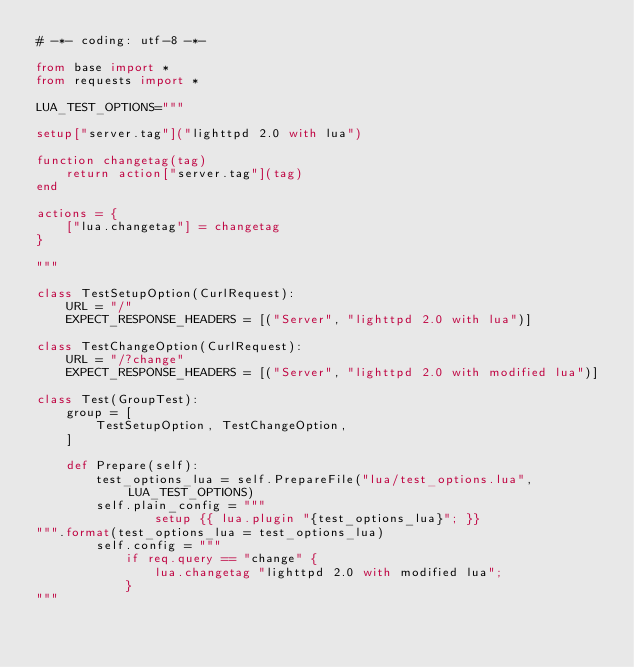Convert code to text. <code><loc_0><loc_0><loc_500><loc_500><_Python_># -*- coding: utf-8 -*-

from base import *
from requests import *

LUA_TEST_OPTIONS="""

setup["server.tag"]("lighttpd 2.0 with lua")

function changetag(tag)
	return action["server.tag"](tag)
end

actions = {
	["lua.changetag"] = changetag
}

"""

class TestSetupOption(CurlRequest):
	URL = "/"
	EXPECT_RESPONSE_HEADERS = [("Server", "lighttpd 2.0 with lua")]

class TestChangeOption(CurlRequest):
	URL = "/?change"
	EXPECT_RESPONSE_HEADERS = [("Server", "lighttpd 2.0 with modified lua")]

class Test(GroupTest):
	group = [
		TestSetupOption, TestChangeOption,
	]

	def Prepare(self):
		test_options_lua = self.PrepareFile("lua/test_options.lua", LUA_TEST_OPTIONS)
		self.plain_config = """
				setup {{ lua.plugin "{test_options_lua}"; }}
""".format(test_options_lua = test_options_lua)
		self.config = """
			if req.query == "change" {
				lua.changetag "lighttpd 2.0 with modified lua";
			}
"""
</code> 